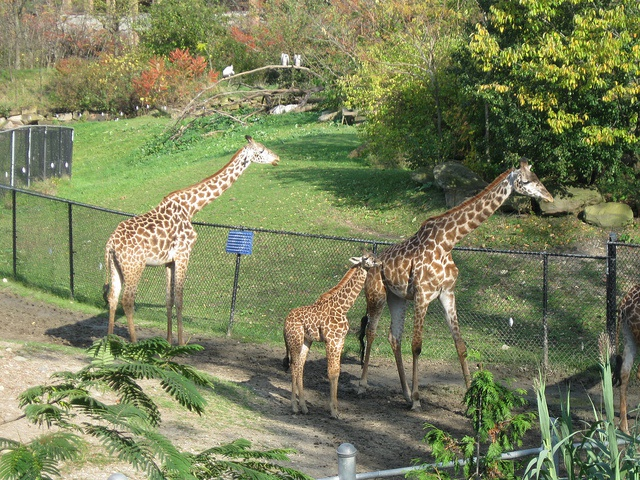Describe the objects in this image and their specific colors. I can see giraffe in tan and gray tones, giraffe in tan and ivory tones, giraffe in tan and gray tones, giraffe in tan, gray, and black tones, and bird in tan, white, gray, darkgray, and beige tones in this image. 